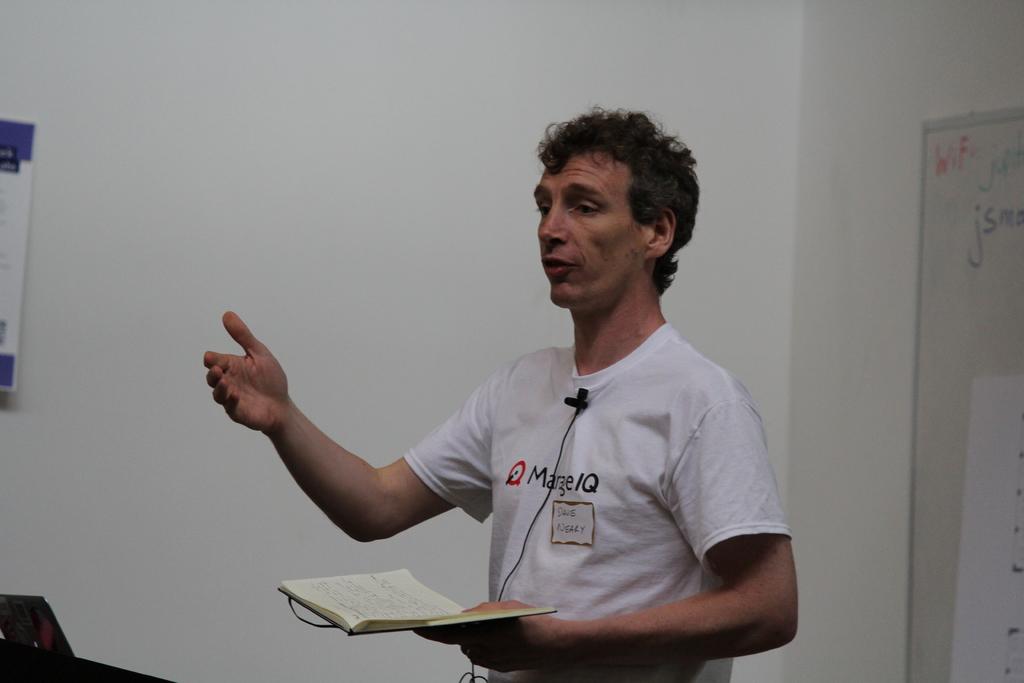What are the last two capital letters on the white shirt?
Provide a succinct answer. Iq. 